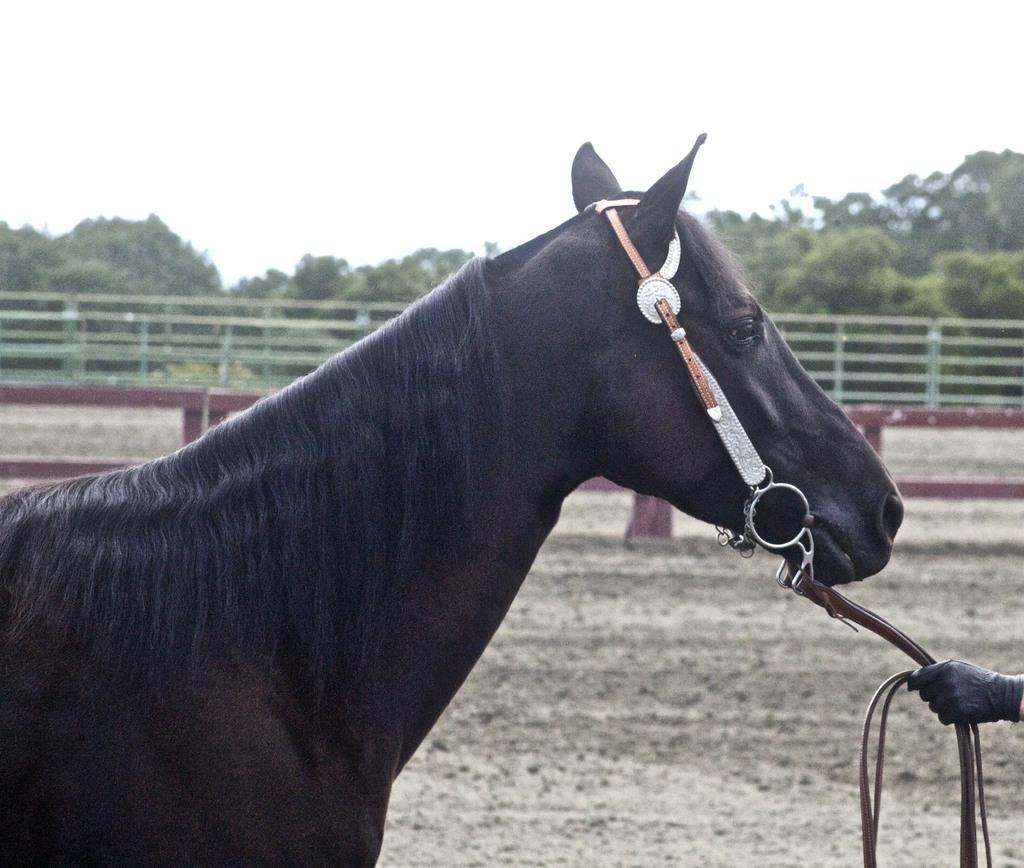What type of animal is in the image? There is a black horse in the image. What is the person in the image holding? A person is holding a rope in the image. What can be seen in the background of the image? Trees are present in the background of the image. What is the color of the sky in the image? The sky appears to be white in the image. How many patches can be seen on the horse's back in the image? There are no patches visible on the horse's back in the image; it is a solid black horse. Can you tell me how many times the person in the image sneezes? There is no indication of the person sneezing in the image. 